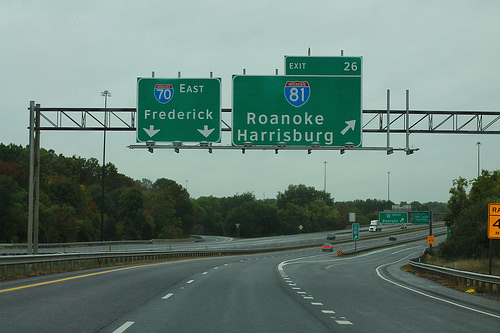<image>
Is there a street sign above the road? Yes. The street sign is positioned above the road in the vertical space, higher up in the scene. 